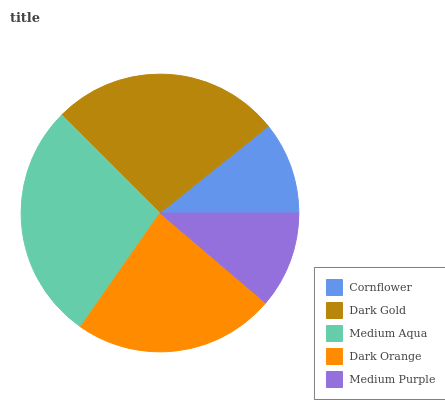Is Cornflower the minimum?
Answer yes or no. Yes. Is Medium Aqua the maximum?
Answer yes or no. Yes. Is Dark Gold the minimum?
Answer yes or no. No. Is Dark Gold the maximum?
Answer yes or no. No. Is Dark Gold greater than Cornflower?
Answer yes or no. Yes. Is Cornflower less than Dark Gold?
Answer yes or no. Yes. Is Cornflower greater than Dark Gold?
Answer yes or no. No. Is Dark Gold less than Cornflower?
Answer yes or no. No. Is Dark Orange the high median?
Answer yes or no. Yes. Is Dark Orange the low median?
Answer yes or no. Yes. Is Cornflower the high median?
Answer yes or no. No. Is Medium Purple the low median?
Answer yes or no. No. 